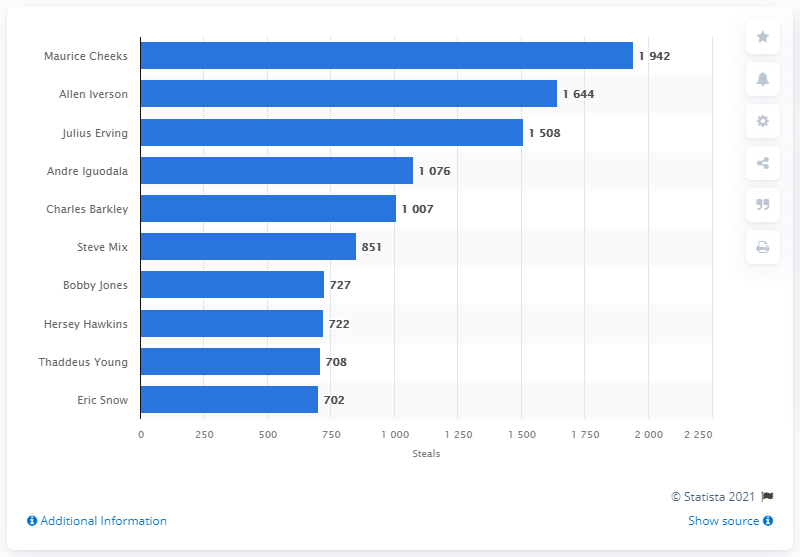Identify some key points in this picture. Maurice Cheeks is the career steals leader among the Philadelphia 76ers. 